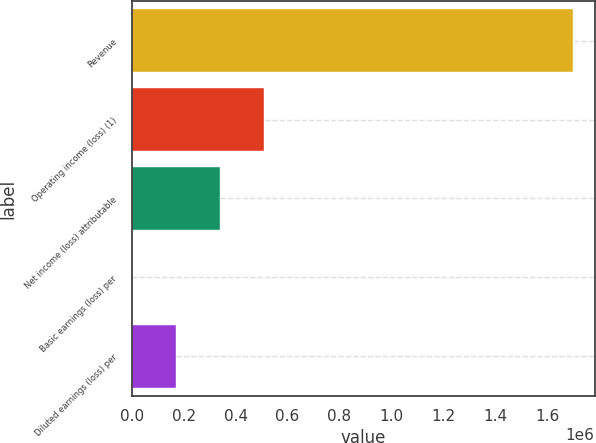<chart> <loc_0><loc_0><loc_500><loc_500><bar_chart><fcel>Revenue<fcel>Operating income (loss) (1)<fcel>Net income (loss) attributable<fcel>Basic earnings (loss) per<fcel>Diluted earnings (loss) per<nl><fcel>1.69857e+06<fcel>509570<fcel>339713<fcel>0.09<fcel>169857<nl></chart> 